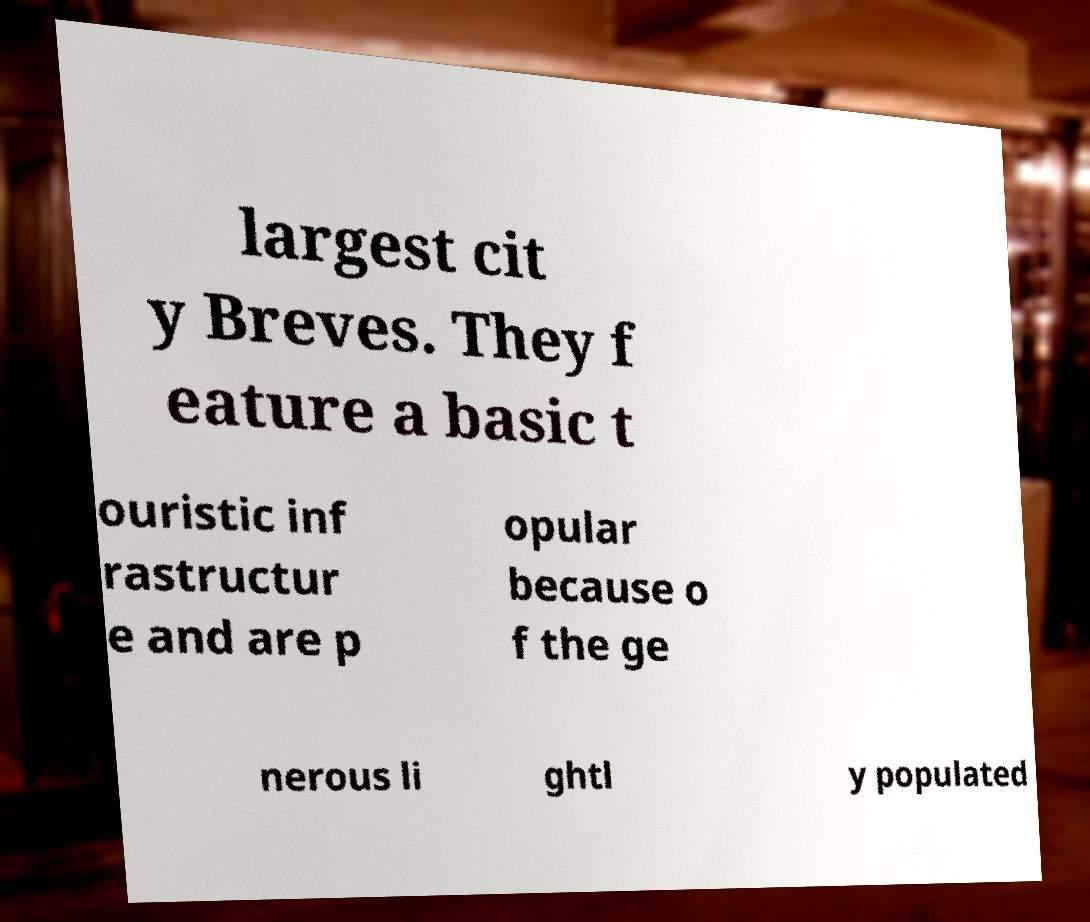I need the written content from this picture converted into text. Can you do that? largest cit y Breves. They f eature a basic t ouristic inf rastructur e and are p opular because o f the ge nerous li ghtl y populated 